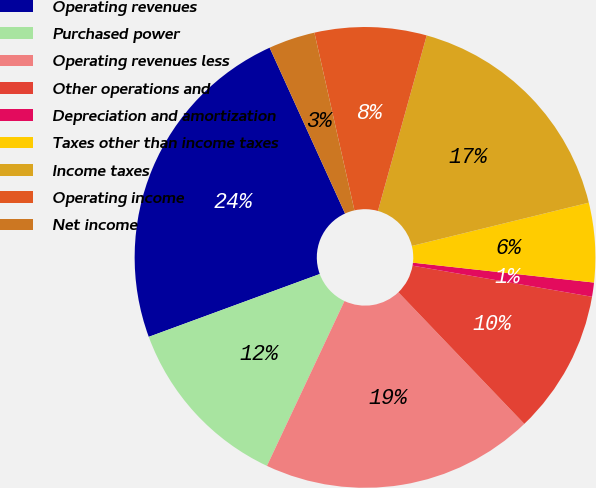Convert chart. <chart><loc_0><loc_0><loc_500><loc_500><pie_chart><fcel>Operating revenues<fcel>Purchased power<fcel>Operating revenues less<fcel>Other operations and<fcel>Depreciation and amortization<fcel>Taxes other than income taxes<fcel>Income taxes<fcel>Operating income<fcel>Net income<nl><fcel>23.81%<fcel>12.4%<fcel>19.15%<fcel>10.12%<fcel>0.99%<fcel>5.56%<fcel>16.87%<fcel>7.84%<fcel>3.27%<nl></chart> 